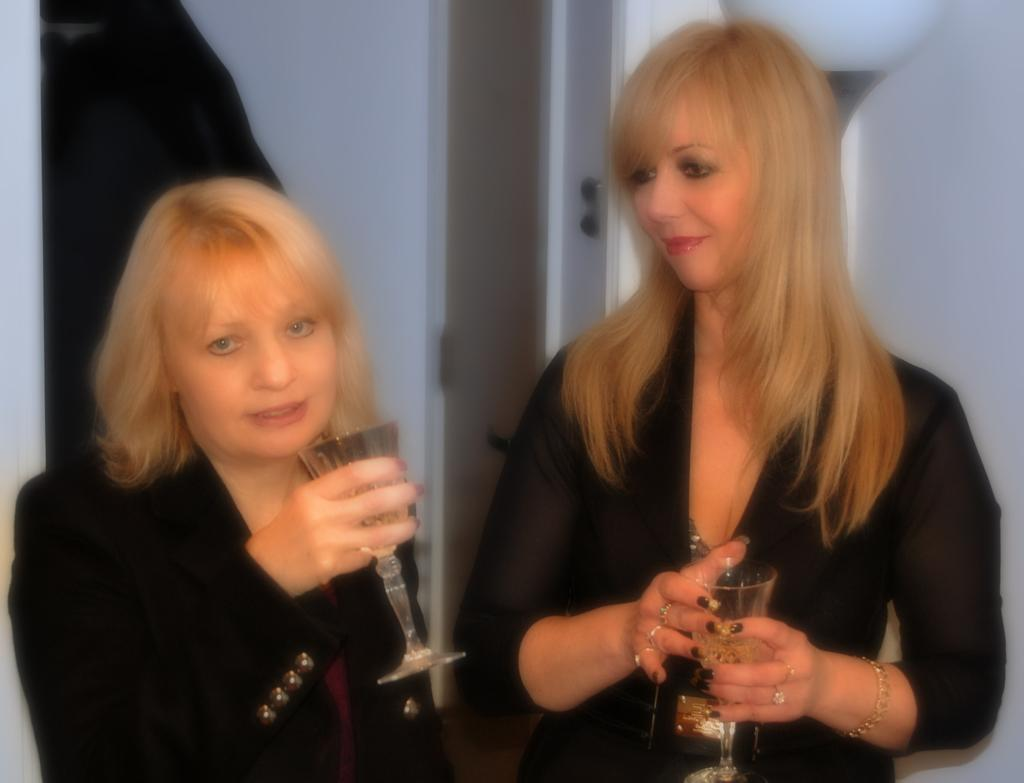How many women are present in the image? There are two women standing in the image. What are the women holding in their hands? Both women are holding glasses. Can you describe the accessories worn by the woman on the right? The woman on the right is wearing bracelets and rings. What can be seen in the background of the image? There is a wall and a door in the background of the image. What type of cap is the wren wearing in the image? There is no wren or cap present in the image; it features two women standing and holding glasses. How is the organization represented in the image? The image does not depict any organization or its representation. 